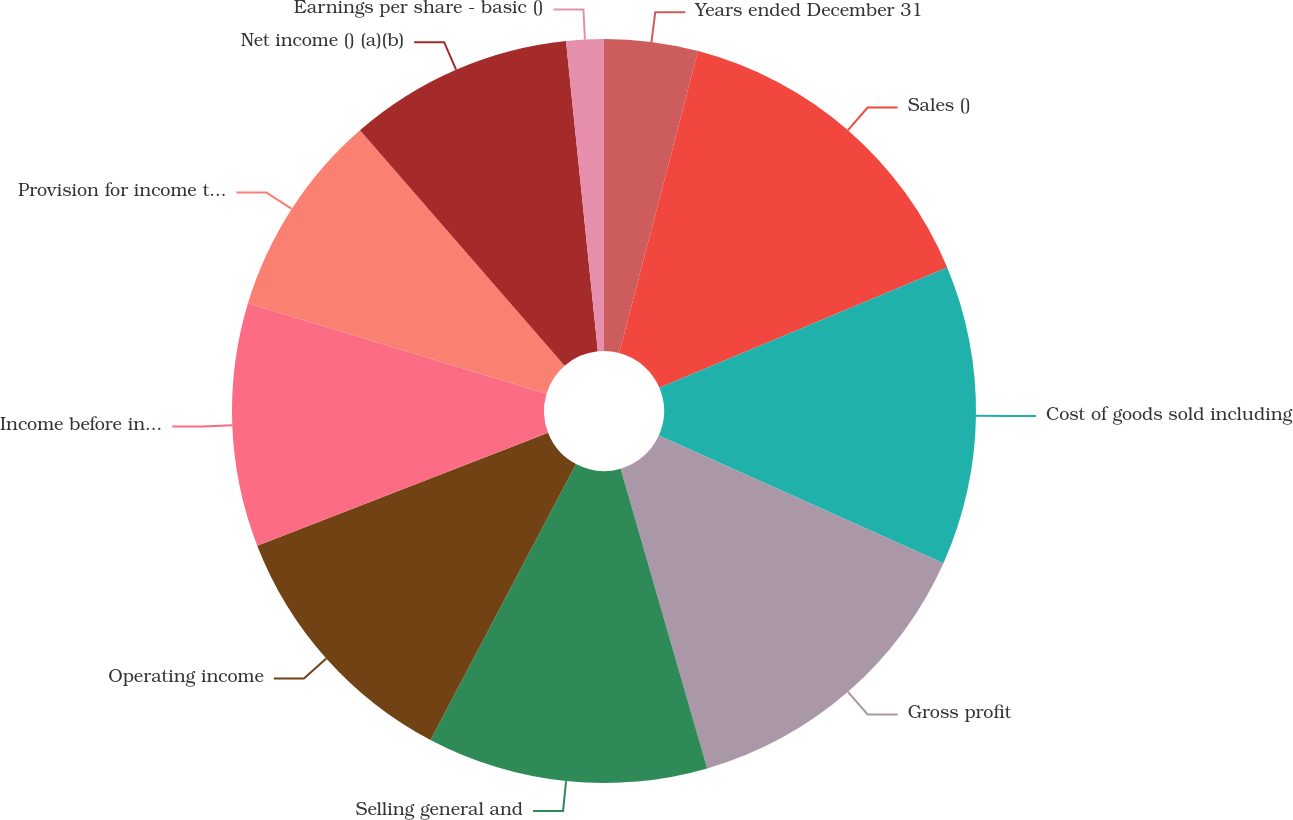<chart> <loc_0><loc_0><loc_500><loc_500><pie_chart><fcel>Years ended December 31<fcel>Sales ()<fcel>Cost of goods sold including<fcel>Gross profit<fcel>Selling general and<fcel>Operating income<fcel>Income before income taxes<fcel>Provision for income taxes (a)<fcel>Net income () (a)(b)<fcel>Earnings per share - basic ()<nl><fcel>4.07%<fcel>14.63%<fcel>13.01%<fcel>13.82%<fcel>12.2%<fcel>11.38%<fcel>10.57%<fcel>8.94%<fcel>9.76%<fcel>1.63%<nl></chart> 